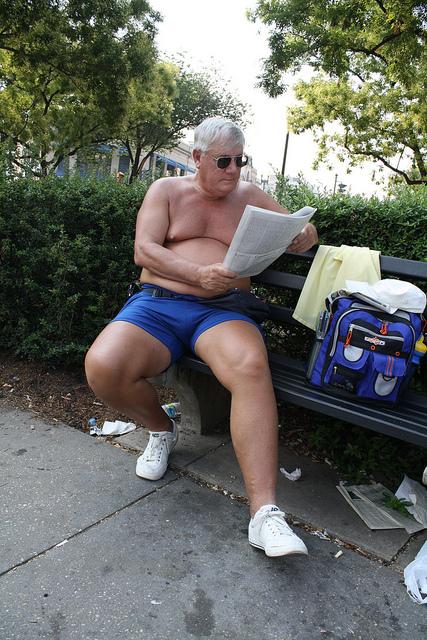Is he wearing sunglasses?
Write a very short answer. Yes. Is the man dressed properly?
Short answer required. No. Is this person old enough to drink beer?
Concise answer only. Yes. What color is his bag?
Answer briefly. Blue. Who is laying out their legs?
Keep it brief. Man. Is the leg that of a woman or a man?
Keep it brief. Man. 